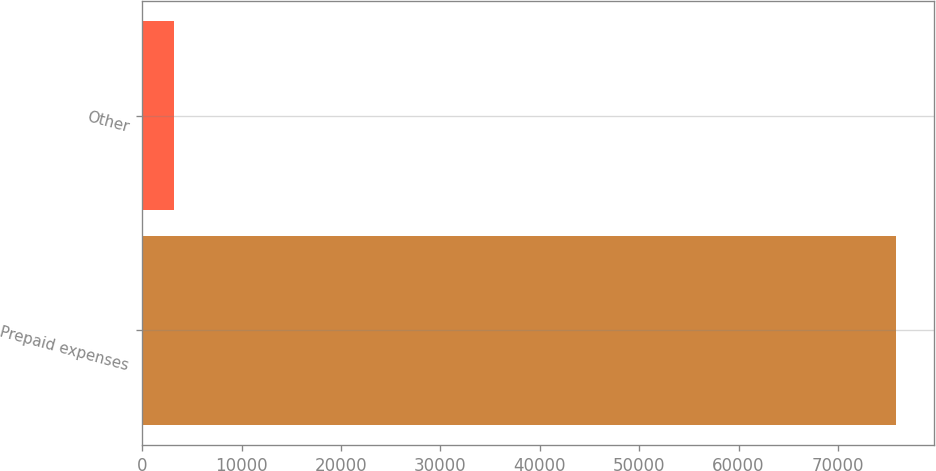Convert chart to OTSL. <chart><loc_0><loc_0><loc_500><loc_500><bar_chart><fcel>Prepaid expenses<fcel>Other<nl><fcel>75853<fcel>3250<nl></chart> 